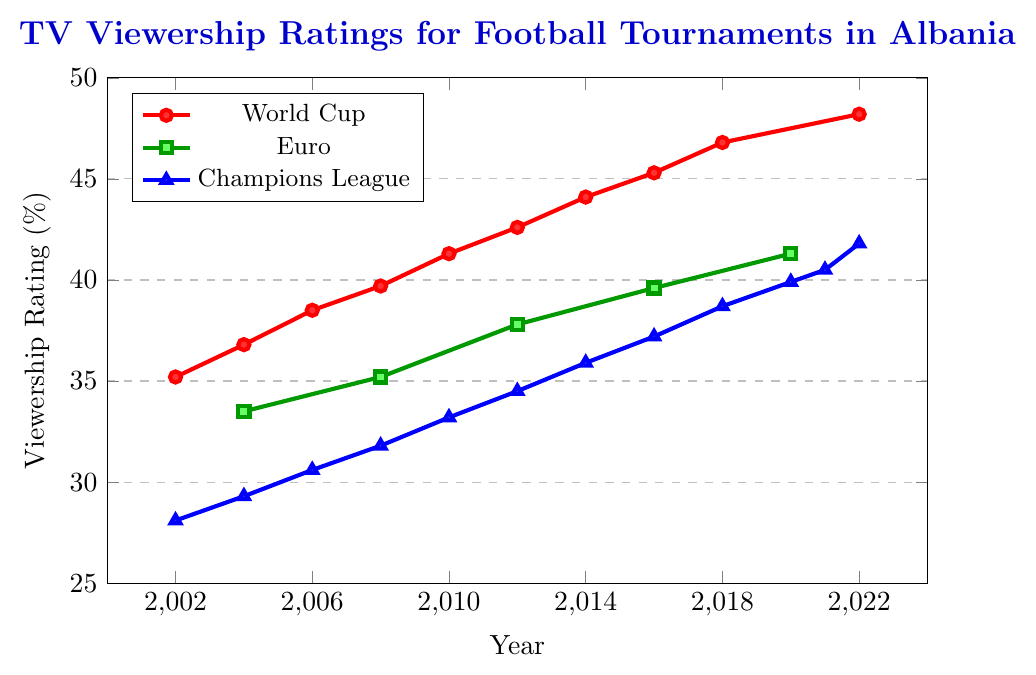What is the trend in TV viewership ratings for the World Cup from 2002 to 2022? The viewership ratings for the World Cup show a consistent upward trend from 35.2% in 2002 to 48.2% in 2022.
Answer: Increasing How did the Euro viewership ratings change from 2004 to 2020? Euro viewership ratings increased from 33.5% in 2004 to 41.3% in 2020.
Answer: Increased Which tournament had the highest viewership rating in 2022 and what was the value? The World Cup had the highest viewership rating in 2022 with 48.2%.
Answer: 48.2% What is the difference in viewership ratings between the World Cup and Champions League in 2012? The World Cup had a rating of 42.6% and the Champions League had a rating of 34.5% in 2012. Subtracting these, 42.6 - 34.5 = 8.1.
Answer: 8.1% Comparing 2016, which tournament had the lowest viewership rating? In 2016, the tournaments had the following viewership ratings: World Cup was 45.3%, Euro was 39.6%, and Champions League was 37.2%. The lowest among these is the Champions League with 37.2%.
Answer: Champions League By how much did the Champions League viewership rating increase from 2002 to 2022? The Champions League viewership rating was 28.1% in 2002 and 41.8% in 2022. The increase is 41.8 - 28.1 = 13.7.
Answer: 13.7% What is the average viewership rating for the Euro tournament from 2004 to 2020? The Euro tournament ratings are 33.5%, 35.2%, 37.8%, 39.6%, and 41.3% from 2004 to 2020. To calculate the average: (33.5 + 35.2 + 37.8 + 39.6 + 41.3) / 5 = 37.48.
Answer: 37.48% Which tournament's rating had the steepest increase from 2004 to 2008? The viewership ratings in 2004 and 2008 for each tournament are:
World Cup: 36.8% to 39.7%, increase of 2.9%
Euro: 33.5% to 35.2%, increase of 1.7%
Champions League: 29.3% to 31.8%, increase of 2.5%
The World Cup had the steepest increase by 2.9%.
Answer: World Cup What was the sum of viewership ratings for all tournaments in the year 2008? The viewership ratings in 2008 for each tournament are: World Cup 39.7%, Euro 35.2%, and Champions League 31.8%.
Sum = 39.7 + 35.2 + 31.8 = 106.7.
Answer: 106.7% In which year did the Champions League first surpass a viewership rating of 40%? The first year the Champions League surpassed 40% was in 2021, with a viewership rating of 40.5%.
Answer: 2021 